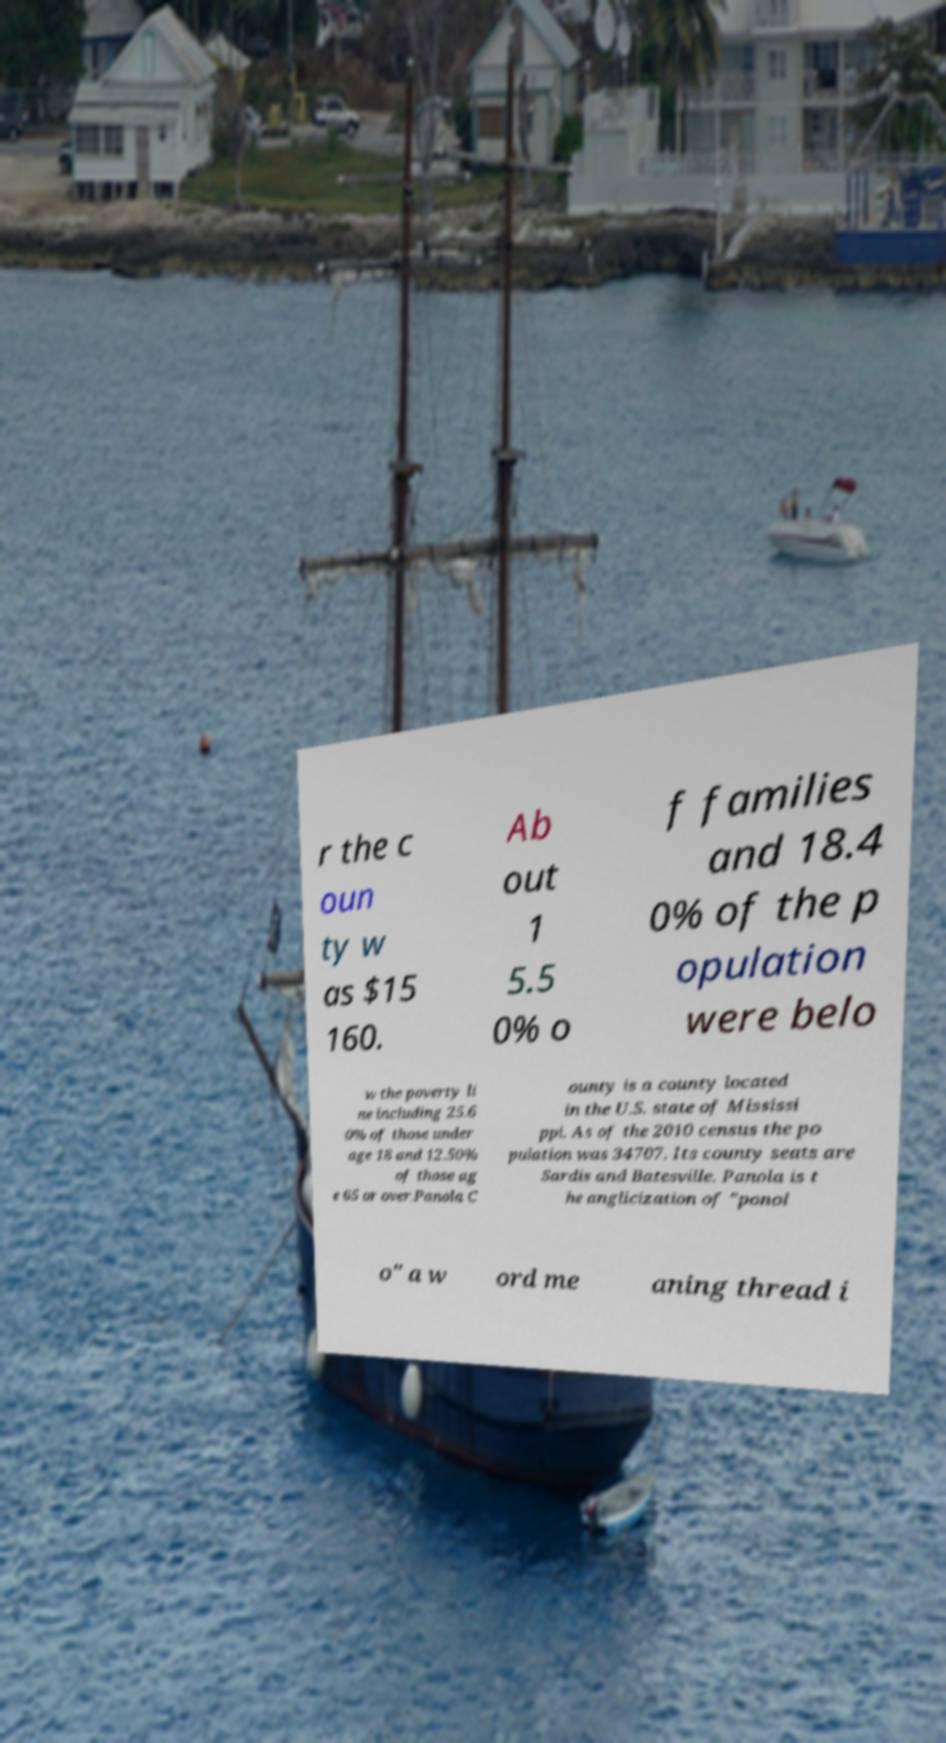For documentation purposes, I need the text within this image transcribed. Could you provide that? r the c oun ty w as $15 160. Ab out 1 5.5 0% o f families and 18.4 0% of the p opulation were belo w the poverty li ne including 25.6 0% of those under age 18 and 12.50% of those ag e 65 or over.Panola C ounty is a county located in the U.S. state of Mississi ppi. As of the 2010 census the po pulation was 34707. Its county seats are Sardis and Batesville. Panola is t he anglicization of "ponol o" a w ord me aning thread i 